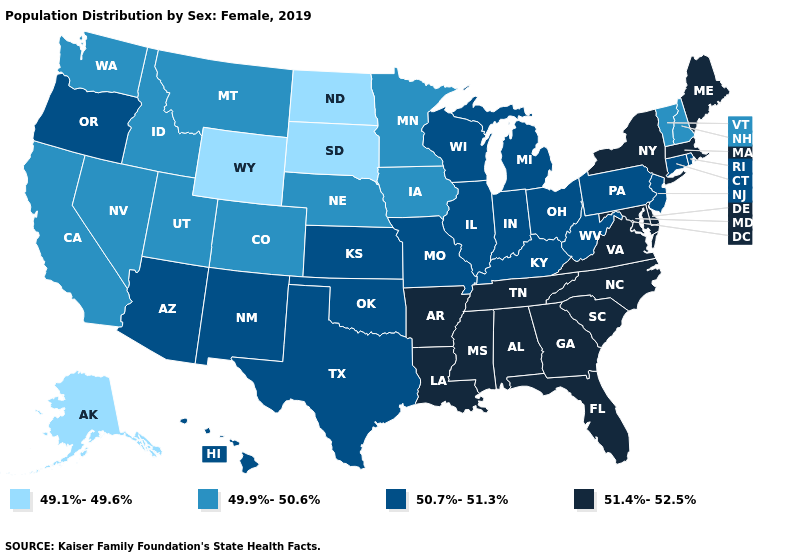What is the highest value in the MidWest ?
Short answer required. 50.7%-51.3%. What is the value of Missouri?
Concise answer only. 50.7%-51.3%. Which states have the lowest value in the USA?
Be succinct. Alaska, North Dakota, South Dakota, Wyoming. What is the value of North Dakota?
Quick response, please. 49.1%-49.6%. What is the value of South Dakota?
Write a very short answer. 49.1%-49.6%. What is the lowest value in the USA?
Give a very brief answer. 49.1%-49.6%. Does Virginia have the highest value in the USA?
Short answer required. Yes. What is the value of South Dakota?
Short answer required. 49.1%-49.6%. Does South Carolina have a higher value than Rhode Island?
Be succinct. Yes. What is the value of Mississippi?
Answer briefly. 51.4%-52.5%. Name the states that have a value in the range 49.9%-50.6%?
Concise answer only. California, Colorado, Idaho, Iowa, Minnesota, Montana, Nebraska, Nevada, New Hampshire, Utah, Vermont, Washington. Does North Dakota have the lowest value in the USA?
Keep it brief. Yes. What is the lowest value in the Northeast?
Give a very brief answer. 49.9%-50.6%. What is the value of Massachusetts?
Be succinct. 51.4%-52.5%. Does North Dakota have the lowest value in the USA?
Quick response, please. Yes. 